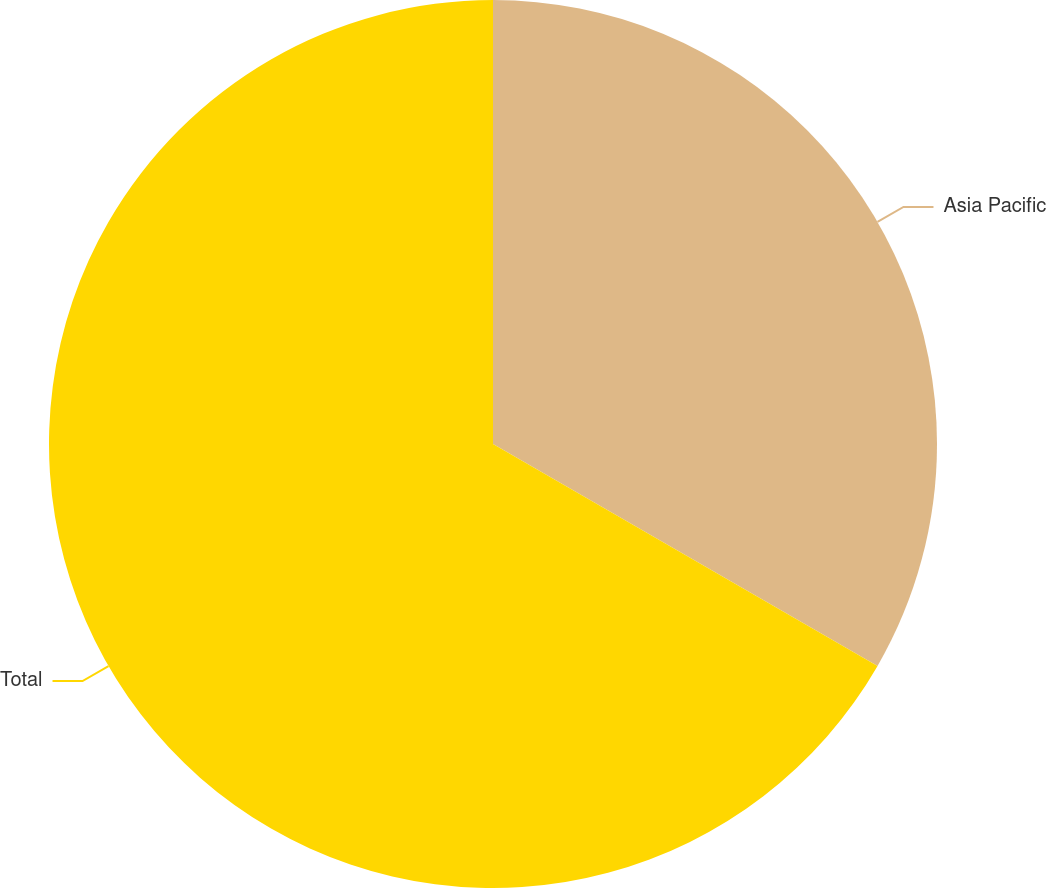<chart> <loc_0><loc_0><loc_500><loc_500><pie_chart><fcel>Asia Pacific<fcel>Total<nl><fcel>33.33%<fcel>66.67%<nl></chart> 